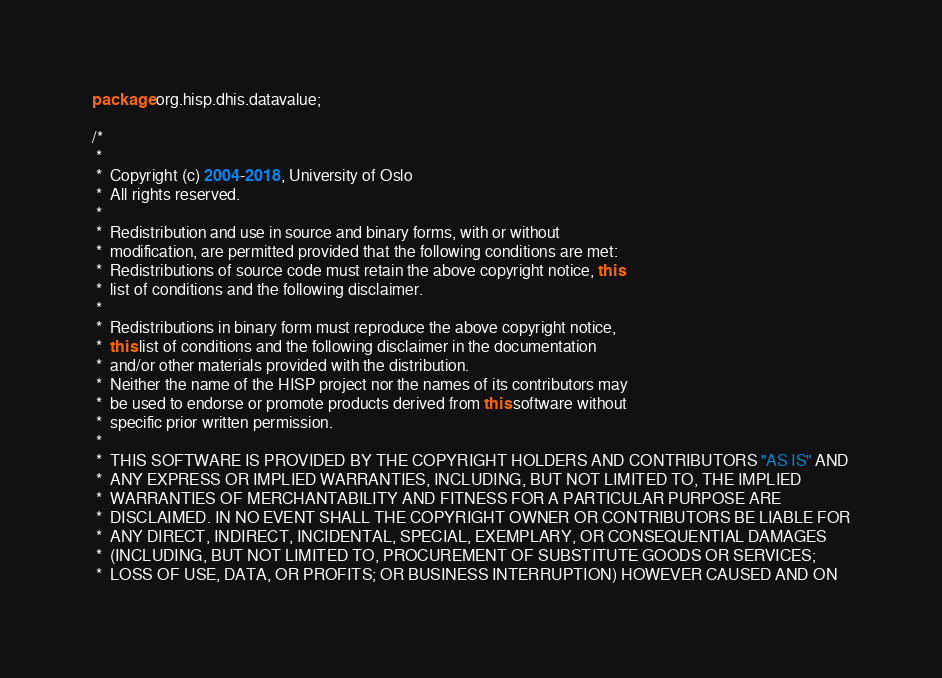Convert code to text. <code><loc_0><loc_0><loc_500><loc_500><_Java_>package org.hisp.dhis.datavalue;

/*
 *
 *  Copyright (c) 2004-2018, University of Oslo
 *  All rights reserved.
 *
 *  Redistribution and use in source and binary forms, with or without
 *  modification, are permitted provided that the following conditions are met:
 *  Redistributions of source code must retain the above copyright notice, this
 *  list of conditions and the following disclaimer.
 *
 *  Redistributions in binary form must reproduce the above copyright notice,
 *  this list of conditions and the following disclaimer in the documentation
 *  and/or other materials provided with the distribution.
 *  Neither the name of the HISP project nor the names of its contributors may
 *  be used to endorse or promote products derived from this software without
 *  specific prior written permission.
 *
 *  THIS SOFTWARE IS PROVIDED BY THE COPYRIGHT HOLDERS AND CONTRIBUTORS "AS IS" AND
 *  ANY EXPRESS OR IMPLIED WARRANTIES, INCLUDING, BUT NOT LIMITED TO, THE IMPLIED
 *  WARRANTIES OF MERCHANTABILITY AND FITNESS FOR A PARTICULAR PURPOSE ARE
 *  DISCLAIMED. IN NO EVENT SHALL THE COPYRIGHT OWNER OR CONTRIBUTORS BE LIABLE FOR
 *  ANY DIRECT, INDIRECT, INCIDENTAL, SPECIAL, EXEMPLARY, OR CONSEQUENTIAL DAMAGES
 *  (INCLUDING, BUT NOT LIMITED TO, PROCUREMENT OF SUBSTITUTE GOODS OR SERVICES;
 *  LOSS OF USE, DATA, OR PROFITS; OR BUSINESS INTERRUPTION) HOWEVER CAUSED AND ON</code> 